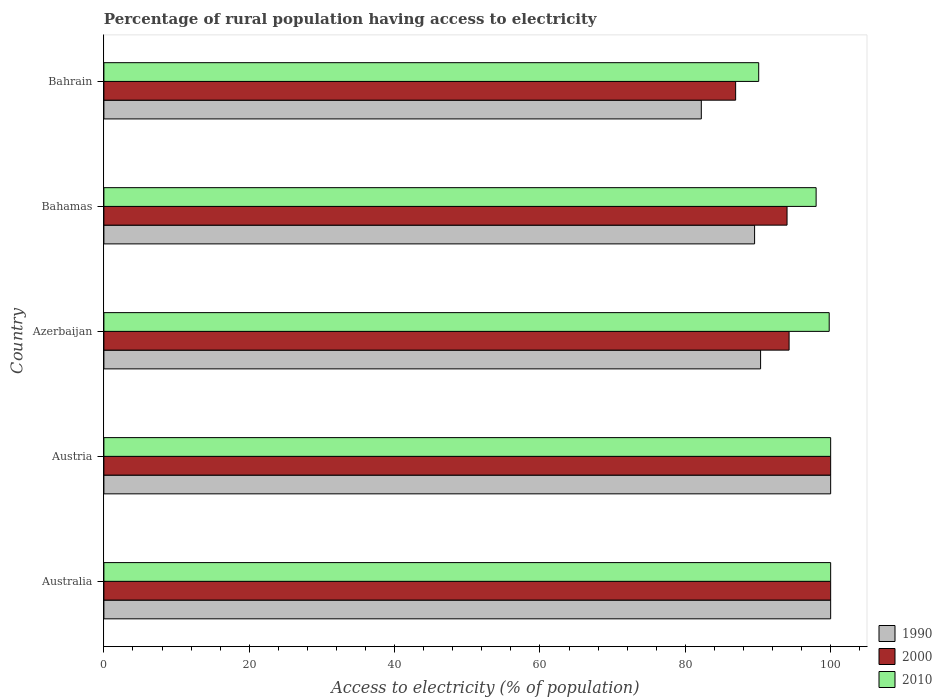Are the number of bars on each tick of the Y-axis equal?
Give a very brief answer. Yes. How many bars are there on the 5th tick from the top?
Give a very brief answer. 3. How many bars are there on the 5th tick from the bottom?
Provide a succinct answer. 3. In how many cases, is the number of bars for a given country not equal to the number of legend labels?
Ensure brevity in your answer.  0. What is the percentage of rural population having access to electricity in 1990 in Bahrain?
Give a very brief answer. 82.2. Across all countries, what is the minimum percentage of rural population having access to electricity in 2000?
Offer a very short reply. 86.93. In which country was the percentage of rural population having access to electricity in 2010 maximum?
Give a very brief answer. Australia. In which country was the percentage of rural population having access to electricity in 2010 minimum?
Ensure brevity in your answer.  Bahrain. What is the total percentage of rural population having access to electricity in 2010 in the graph?
Your answer should be compact. 487.9. What is the difference between the percentage of rural population having access to electricity in 2010 in Azerbaijan and that in Bahrain?
Your answer should be very brief. 9.7. What is the difference between the percentage of rural population having access to electricity in 1990 in Azerbaijan and the percentage of rural population having access to electricity in 2010 in Australia?
Ensure brevity in your answer.  -9.64. What is the average percentage of rural population having access to electricity in 2010 per country?
Give a very brief answer. 97.58. What is the difference between the percentage of rural population having access to electricity in 2010 and percentage of rural population having access to electricity in 1990 in Bahamas?
Offer a terse response. 8.47. In how many countries, is the percentage of rural population having access to electricity in 2010 greater than 4 %?
Give a very brief answer. 5. What is the ratio of the percentage of rural population having access to electricity in 2000 in Azerbaijan to that in Bahrain?
Make the answer very short. 1.08. What is the difference between the highest and the second highest percentage of rural population having access to electricity in 1990?
Your response must be concise. 0. What is the difference between the highest and the lowest percentage of rural population having access to electricity in 2010?
Provide a succinct answer. 9.9. What does the 2nd bar from the top in Austria represents?
Provide a succinct answer. 2000. Is it the case that in every country, the sum of the percentage of rural population having access to electricity in 2000 and percentage of rural population having access to electricity in 1990 is greater than the percentage of rural population having access to electricity in 2010?
Your response must be concise. Yes. How many bars are there?
Make the answer very short. 15. Are all the bars in the graph horizontal?
Give a very brief answer. Yes. Are the values on the major ticks of X-axis written in scientific E-notation?
Provide a succinct answer. No. Does the graph contain grids?
Keep it short and to the point. No. How are the legend labels stacked?
Keep it short and to the point. Vertical. What is the title of the graph?
Your response must be concise. Percentage of rural population having access to electricity. What is the label or title of the X-axis?
Your response must be concise. Access to electricity (% of population). What is the Access to electricity (% of population) in 1990 in Australia?
Your response must be concise. 100. What is the Access to electricity (% of population) in 2000 in Australia?
Your answer should be compact. 100. What is the Access to electricity (% of population) of 2010 in Australia?
Your answer should be very brief. 100. What is the Access to electricity (% of population) of 2010 in Austria?
Your response must be concise. 100. What is the Access to electricity (% of population) in 1990 in Azerbaijan?
Give a very brief answer. 90.36. What is the Access to electricity (% of population) in 2000 in Azerbaijan?
Ensure brevity in your answer.  94.28. What is the Access to electricity (% of population) of 2010 in Azerbaijan?
Make the answer very short. 99.8. What is the Access to electricity (% of population) in 1990 in Bahamas?
Provide a short and direct response. 89.53. What is the Access to electricity (% of population) in 2000 in Bahamas?
Offer a terse response. 94. What is the Access to electricity (% of population) in 2010 in Bahamas?
Offer a terse response. 98. What is the Access to electricity (% of population) in 1990 in Bahrain?
Offer a terse response. 82.2. What is the Access to electricity (% of population) of 2000 in Bahrain?
Offer a terse response. 86.93. What is the Access to electricity (% of population) in 2010 in Bahrain?
Keep it short and to the point. 90.1. Across all countries, what is the maximum Access to electricity (% of population) of 2010?
Offer a very short reply. 100. Across all countries, what is the minimum Access to electricity (% of population) of 1990?
Offer a terse response. 82.2. Across all countries, what is the minimum Access to electricity (% of population) of 2000?
Offer a terse response. 86.93. Across all countries, what is the minimum Access to electricity (% of population) in 2010?
Give a very brief answer. 90.1. What is the total Access to electricity (% of population) in 1990 in the graph?
Provide a succinct answer. 462.1. What is the total Access to electricity (% of population) in 2000 in the graph?
Your response must be concise. 475.21. What is the total Access to electricity (% of population) in 2010 in the graph?
Keep it short and to the point. 487.9. What is the difference between the Access to electricity (% of population) of 2010 in Australia and that in Austria?
Make the answer very short. 0. What is the difference between the Access to electricity (% of population) of 1990 in Australia and that in Azerbaijan?
Ensure brevity in your answer.  9.64. What is the difference between the Access to electricity (% of population) of 2000 in Australia and that in Azerbaijan?
Provide a short and direct response. 5.72. What is the difference between the Access to electricity (% of population) of 2010 in Australia and that in Azerbaijan?
Ensure brevity in your answer.  0.2. What is the difference between the Access to electricity (% of population) in 1990 in Australia and that in Bahamas?
Make the answer very short. 10.47. What is the difference between the Access to electricity (% of population) in 2000 in Australia and that in Bahamas?
Provide a succinct answer. 6. What is the difference between the Access to electricity (% of population) of 2010 in Australia and that in Bahamas?
Your answer should be compact. 2. What is the difference between the Access to electricity (% of population) in 1990 in Australia and that in Bahrain?
Your answer should be compact. 17.8. What is the difference between the Access to electricity (% of population) in 2000 in Australia and that in Bahrain?
Make the answer very short. 13.07. What is the difference between the Access to electricity (% of population) in 2010 in Australia and that in Bahrain?
Keep it short and to the point. 9.9. What is the difference between the Access to electricity (% of population) in 1990 in Austria and that in Azerbaijan?
Your answer should be very brief. 9.64. What is the difference between the Access to electricity (% of population) in 2000 in Austria and that in Azerbaijan?
Your response must be concise. 5.72. What is the difference between the Access to electricity (% of population) of 2010 in Austria and that in Azerbaijan?
Your answer should be compact. 0.2. What is the difference between the Access to electricity (% of population) of 1990 in Austria and that in Bahamas?
Give a very brief answer. 10.47. What is the difference between the Access to electricity (% of population) of 2000 in Austria and that in Bahamas?
Your response must be concise. 6. What is the difference between the Access to electricity (% of population) of 2010 in Austria and that in Bahamas?
Your response must be concise. 2. What is the difference between the Access to electricity (% of population) in 1990 in Austria and that in Bahrain?
Ensure brevity in your answer.  17.8. What is the difference between the Access to electricity (% of population) of 2000 in Austria and that in Bahrain?
Your answer should be very brief. 13.07. What is the difference between the Access to electricity (% of population) of 1990 in Azerbaijan and that in Bahamas?
Make the answer very short. 0.83. What is the difference between the Access to electricity (% of population) in 2000 in Azerbaijan and that in Bahamas?
Your answer should be very brief. 0.28. What is the difference between the Access to electricity (% of population) of 2010 in Azerbaijan and that in Bahamas?
Your answer should be very brief. 1.8. What is the difference between the Access to electricity (% of population) in 1990 in Azerbaijan and that in Bahrain?
Your response must be concise. 8.16. What is the difference between the Access to electricity (% of population) in 2000 in Azerbaijan and that in Bahrain?
Offer a very short reply. 7.35. What is the difference between the Access to electricity (% of population) of 1990 in Bahamas and that in Bahrain?
Offer a very short reply. 7.33. What is the difference between the Access to electricity (% of population) of 2000 in Bahamas and that in Bahrain?
Ensure brevity in your answer.  7.07. What is the difference between the Access to electricity (% of population) in 2010 in Bahamas and that in Bahrain?
Give a very brief answer. 7.9. What is the difference between the Access to electricity (% of population) of 1990 in Australia and the Access to electricity (% of population) of 2000 in Azerbaijan?
Ensure brevity in your answer.  5.72. What is the difference between the Access to electricity (% of population) in 1990 in Australia and the Access to electricity (% of population) in 2010 in Azerbaijan?
Ensure brevity in your answer.  0.2. What is the difference between the Access to electricity (% of population) of 2000 in Australia and the Access to electricity (% of population) of 2010 in Bahamas?
Provide a short and direct response. 2. What is the difference between the Access to electricity (% of population) in 1990 in Australia and the Access to electricity (% of population) in 2000 in Bahrain?
Give a very brief answer. 13.07. What is the difference between the Access to electricity (% of population) in 1990 in Austria and the Access to electricity (% of population) in 2000 in Azerbaijan?
Provide a short and direct response. 5.72. What is the difference between the Access to electricity (% of population) of 1990 in Austria and the Access to electricity (% of population) of 2010 in Azerbaijan?
Ensure brevity in your answer.  0.2. What is the difference between the Access to electricity (% of population) in 2000 in Austria and the Access to electricity (% of population) in 2010 in Azerbaijan?
Offer a very short reply. 0.2. What is the difference between the Access to electricity (% of population) in 1990 in Austria and the Access to electricity (% of population) in 2000 in Bahamas?
Ensure brevity in your answer.  6. What is the difference between the Access to electricity (% of population) in 1990 in Austria and the Access to electricity (% of population) in 2010 in Bahamas?
Your answer should be very brief. 2. What is the difference between the Access to electricity (% of population) of 1990 in Austria and the Access to electricity (% of population) of 2000 in Bahrain?
Provide a succinct answer. 13.07. What is the difference between the Access to electricity (% of population) of 2000 in Austria and the Access to electricity (% of population) of 2010 in Bahrain?
Offer a terse response. 9.9. What is the difference between the Access to electricity (% of population) in 1990 in Azerbaijan and the Access to electricity (% of population) in 2000 in Bahamas?
Offer a terse response. -3.64. What is the difference between the Access to electricity (% of population) of 1990 in Azerbaijan and the Access to electricity (% of population) of 2010 in Bahamas?
Provide a succinct answer. -7.64. What is the difference between the Access to electricity (% of population) in 2000 in Azerbaijan and the Access to electricity (% of population) in 2010 in Bahamas?
Make the answer very short. -3.72. What is the difference between the Access to electricity (% of population) of 1990 in Azerbaijan and the Access to electricity (% of population) of 2000 in Bahrain?
Give a very brief answer. 3.43. What is the difference between the Access to electricity (% of population) of 1990 in Azerbaijan and the Access to electricity (% of population) of 2010 in Bahrain?
Offer a terse response. 0.26. What is the difference between the Access to electricity (% of population) in 2000 in Azerbaijan and the Access to electricity (% of population) in 2010 in Bahrain?
Your answer should be compact. 4.18. What is the difference between the Access to electricity (% of population) in 1990 in Bahamas and the Access to electricity (% of population) in 2000 in Bahrain?
Your answer should be compact. 2.61. What is the difference between the Access to electricity (% of population) of 1990 in Bahamas and the Access to electricity (% of population) of 2010 in Bahrain?
Keep it short and to the point. -0.57. What is the average Access to electricity (% of population) of 1990 per country?
Ensure brevity in your answer.  92.42. What is the average Access to electricity (% of population) of 2000 per country?
Make the answer very short. 95.04. What is the average Access to electricity (% of population) of 2010 per country?
Keep it short and to the point. 97.58. What is the difference between the Access to electricity (% of population) in 1990 and Access to electricity (% of population) in 2000 in Australia?
Give a very brief answer. 0. What is the difference between the Access to electricity (% of population) in 1990 and Access to electricity (% of population) in 2010 in Australia?
Offer a very short reply. 0. What is the difference between the Access to electricity (% of population) in 1990 and Access to electricity (% of population) in 2010 in Austria?
Your response must be concise. 0. What is the difference between the Access to electricity (% of population) in 2000 and Access to electricity (% of population) in 2010 in Austria?
Provide a short and direct response. 0. What is the difference between the Access to electricity (% of population) in 1990 and Access to electricity (% of population) in 2000 in Azerbaijan?
Offer a very short reply. -3.92. What is the difference between the Access to electricity (% of population) in 1990 and Access to electricity (% of population) in 2010 in Azerbaijan?
Offer a very short reply. -9.44. What is the difference between the Access to electricity (% of population) of 2000 and Access to electricity (% of population) of 2010 in Azerbaijan?
Ensure brevity in your answer.  -5.52. What is the difference between the Access to electricity (% of population) in 1990 and Access to electricity (% of population) in 2000 in Bahamas?
Offer a terse response. -4.47. What is the difference between the Access to electricity (% of population) of 1990 and Access to electricity (% of population) of 2010 in Bahamas?
Ensure brevity in your answer.  -8.47. What is the difference between the Access to electricity (% of population) of 1990 and Access to electricity (% of population) of 2000 in Bahrain?
Ensure brevity in your answer.  -4.72. What is the difference between the Access to electricity (% of population) in 1990 and Access to electricity (% of population) in 2010 in Bahrain?
Offer a very short reply. -7.9. What is the difference between the Access to electricity (% of population) in 2000 and Access to electricity (% of population) in 2010 in Bahrain?
Ensure brevity in your answer.  -3.17. What is the ratio of the Access to electricity (% of population) in 2010 in Australia to that in Austria?
Provide a short and direct response. 1. What is the ratio of the Access to electricity (% of population) of 1990 in Australia to that in Azerbaijan?
Ensure brevity in your answer.  1.11. What is the ratio of the Access to electricity (% of population) in 2000 in Australia to that in Azerbaijan?
Your response must be concise. 1.06. What is the ratio of the Access to electricity (% of population) of 2010 in Australia to that in Azerbaijan?
Your answer should be very brief. 1. What is the ratio of the Access to electricity (% of population) in 1990 in Australia to that in Bahamas?
Make the answer very short. 1.12. What is the ratio of the Access to electricity (% of population) in 2000 in Australia to that in Bahamas?
Offer a terse response. 1.06. What is the ratio of the Access to electricity (% of population) of 2010 in Australia to that in Bahamas?
Ensure brevity in your answer.  1.02. What is the ratio of the Access to electricity (% of population) of 1990 in Australia to that in Bahrain?
Your answer should be compact. 1.22. What is the ratio of the Access to electricity (% of population) in 2000 in Australia to that in Bahrain?
Your answer should be compact. 1.15. What is the ratio of the Access to electricity (% of population) of 2010 in Australia to that in Bahrain?
Your response must be concise. 1.11. What is the ratio of the Access to electricity (% of population) of 1990 in Austria to that in Azerbaijan?
Your response must be concise. 1.11. What is the ratio of the Access to electricity (% of population) of 2000 in Austria to that in Azerbaijan?
Provide a short and direct response. 1.06. What is the ratio of the Access to electricity (% of population) in 2010 in Austria to that in Azerbaijan?
Provide a short and direct response. 1. What is the ratio of the Access to electricity (% of population) of 1990 in Austria to that in Bahamas?
Give a very brief answer. 1.12. What is the ratio of the Access to electricity (% of population) of 2000 in Austria to that in Bahamas?
Provide a short and direct response. 1.06. What is the ratio of the Access to electricity (% of population) of 2010 in Austria to that in Bahamas?
Ensure brevity in your answer.  1.02. What is the ratio of the Access to electricity (% of population) in 1990 in Austria to that in Bahrain?
Your answer should be very brief. 1.22. What is the ratio of the Access to electricity (% of population) of 2000 in Austria to that in Bahrain?
Provide a short and direct response. 1.15. What is the ratio of the Access to electricity (% of population) in 2010 in Austria to that in Bahrain?
Make the answer very short. 1.11. What is the ratio of the Access to electricity (% of population) of 1990 in Azerbaijan to that in Bahamas?
Keep it short and to the point. 1.01. What is the ratio of the Access to electricity (% of population) of 2010 in Azerbaijan to that in Bahamas?
Provide a succinct answer. 1.02. What is the ratio of the Access to electricity (% of population) of 1990 in Azerbaijan to that in Bahrain?
Ensure brevity in your answer.  1.1. What is the ratio of the Access to electricity (% of population) of 2000 in Azerbaijan to that in Bahrain?
Make the answer very short. 1.08. What is the ratio of the Access to electricity (% of population) in 2010 in Azerbaijan to that in Bahrain?
Provide a short and direct response. 1.11. What is the ratio of the Access to electricity (% of population) of 1990 in Bahamas to that in Bahrain?
Ensure brevity in your answer.  1.09. What is the ratio of the Access to electricity (% of population) of 2000 in Bahamas to that in Bahrain?
Make the answer very short. 1.08. What is the ratio of the Access to electricity (% of population) of 2010 in Bahamas to that in Bahrain?
Your answer should be compact. 1.09. What is the difference between the highest and the second highest Access to electricity (% of population) in 1990?
Give a very brief answer. 0. What is the difference between the highest and the second highest Access to electricity (% of population) in 2000?
Ensure brevity in your answer.  0. What is the difference between the highest and the lowest Access to electricity (% of population) in 1990?
Give a very brief answer. 17.8. What is the difference between the highest and the lowest Access to electricity (% of population) in 2000?
Your answer should be compact. 13.07. What is the difference between the highest and the lowest Access to electricity (% of population) in 2010?
Offer a terse response. 9.9. 